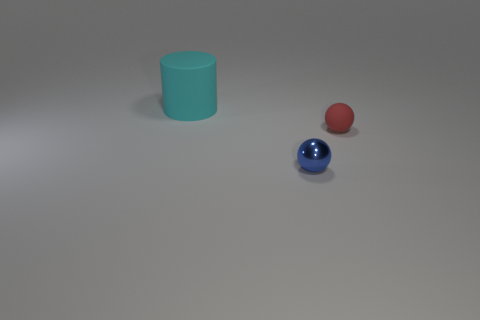Add 2 large cylinders. How many objects exist? 5 Subtract all balls. How many objects are left? 1 Add 1 big cyan objects. How many big cyan objects exist? 2 Subtract 0 yellow cylinders. How many objects are left? 3 Subtract all blue spheres. Subtract all tiny yellow metal spheres. How many objects are left? 2 Add 3 tiny metal objects. How many tiny metal objects are left? 4 